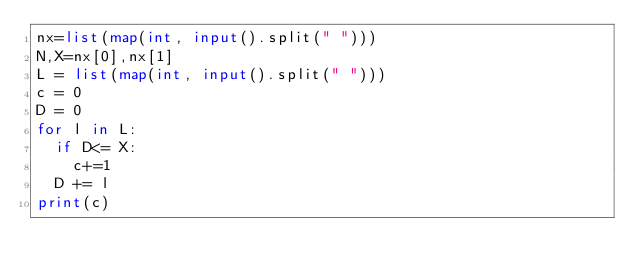Convert code to text. <code><loc_0><loc_0><loc_500><loc_500><_Python_>nx=list(map(int, input().split(" ")))
N,X=nx[0],nx[1]
L = list(map(int, input().split(" ")))
c = 0
D = 0
for l in L:
  if D<= X:
    c+=1
  D += l
print(c)</code> 